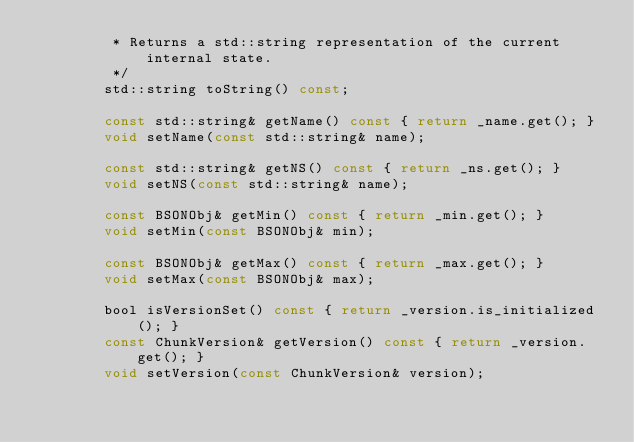<code> <loc_0><loc_0><loc_500><loc_500><_C_>         * Returns a std::string representation of the current internal state.
         */
        std::string toString() const;

        const std::string& getName() const { return _name.get(); }
        void setName(const std::string& name);

        const std::string& getNS() const { return _ns.get(); }
        void setNS(const std::string& name);

        const BSONObj& getMin() const { return _min.get(); }
        void setMin(const BSONObj& min);

        const BSONObj& getMax() const { return _max.get(); }
        void setMax(const BSONObj& max);

        bool isVersionSet() const { return _version.is_initialized(); }
        const ChunkVersion& getVersion() const { return _version.get(); }
        void setVersion(const ChunkVersion& version);
</code> 